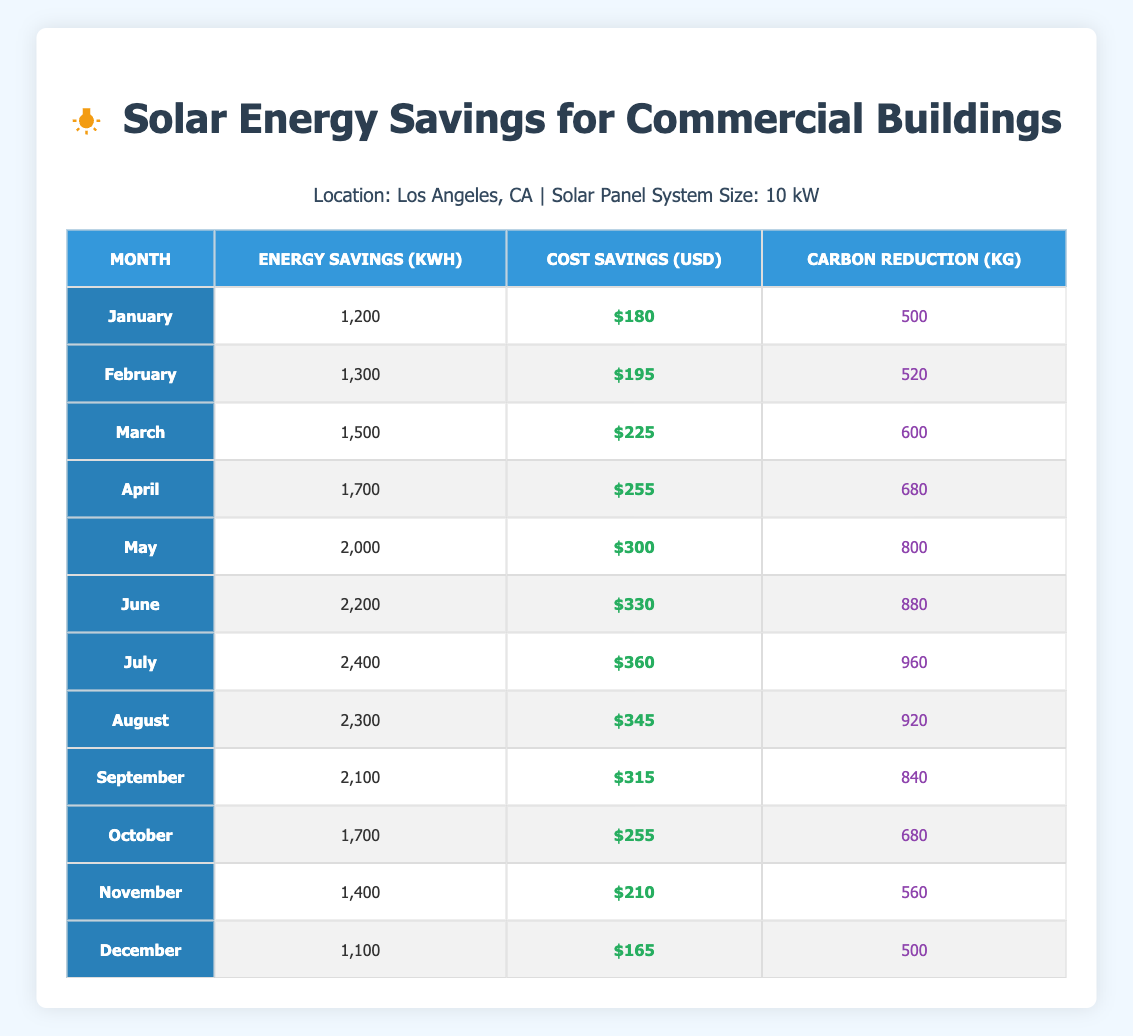What is the total energy savings for the months from April to June? To find the total energy savings from April to June, we need to sum the energy savings for those months: April (1,700 kWh) + May (2,000 kWh) + June (2,200 kWh) = 1,700 + 2,000 + 2,200 = 5,900 kWh.
Answer: 5,900 kWh During which month does the highest cost savings occur? By checking the cost savings column, we see that July has the highest value at $360.
Answer: July What is the average carbon reduction from January to March? We need to find the carbon reduction for January (500 kg), February (520 kg), and March (600 kg). Summing them gives: 500 + 520 + 600 = 1,620 kg. Dividing by 3 (the number of months) gives 1,620 / 3 = 540 kg.
Answer: 540 kg Is the total cost savings for the year greater than $3,500? To answer this, we sum the cost savings for all months: $180 + $195 + $225 + $255 + $300 + $330 + $360 + $345 + $315 + $255 + $210 + $165 = $3,450. $3,450 is not greater than $3,500, so the answer is no.
Answer: No How much more energy is saved in July compared to December? The energy savings for July is 2,400 kWh and for December is 1,100 kWh. The difference is 2,400 - 1,100 = 1,300 kWh.
Answer: 1,300 kWh What is the median cost savings for the months listed? Sorting the cost savings values: $165, $180, $195, $210, $225, $255, $300, $315, $330, $345, $360. With 12 values, the median is the average of the 6th and 7th values: ($255 + $300) / 2 = $277.50.
Answer: $277.50 Does August have energy savings lower than September? The energy savings for August is 2,300 kWh while for September it is 2,100 kWh. Since 2,300 kWh is greater than 2,100 kWh, the answer is no.
Answer: No What is the percentage increase in cost savings from January to July? The cost savings in January is $180 and in July is $360. The increase is $360 - $180 = $180. The percentage increase is ($180 / $180) x 100 = 100%.
Answer: 100% 